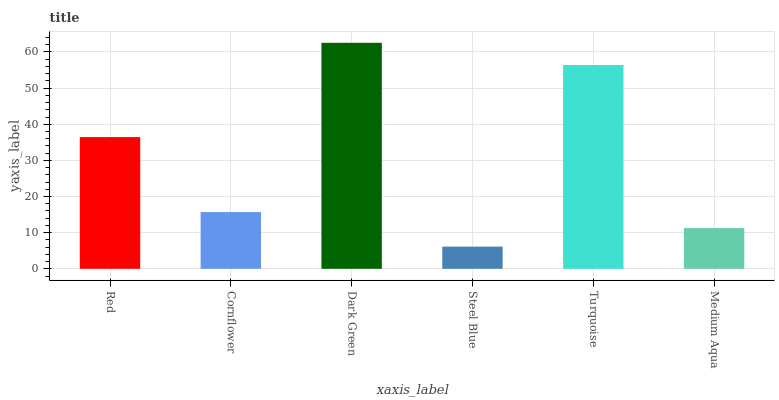Is Steel Blue the minimum?
Answer yes or no. Yes. Is Dark Green the maximum?
Answer yes or no. Yes. Is Cornflower the minimum?
Answer yes or no. No. Is Cornflower the maximum?
Answer yes or no. No. Is Red greater than Cornflower?
Answer yes or no. Yes. Is Cornflower less than Red?
Answer yes or no. Yes. Is Cornflower greater than Red?
Answer yes or no. No. Is Red less than Cornflower?
Answer yes or no. No. Is Red the high median?
Answer yes or no. Yes. Is Cornflower the low median?
Answer yes or no. Yes. Is Cornflower the high median?
Answer yes or no. No. Is Red the low median?
Answer yes or no. No. 